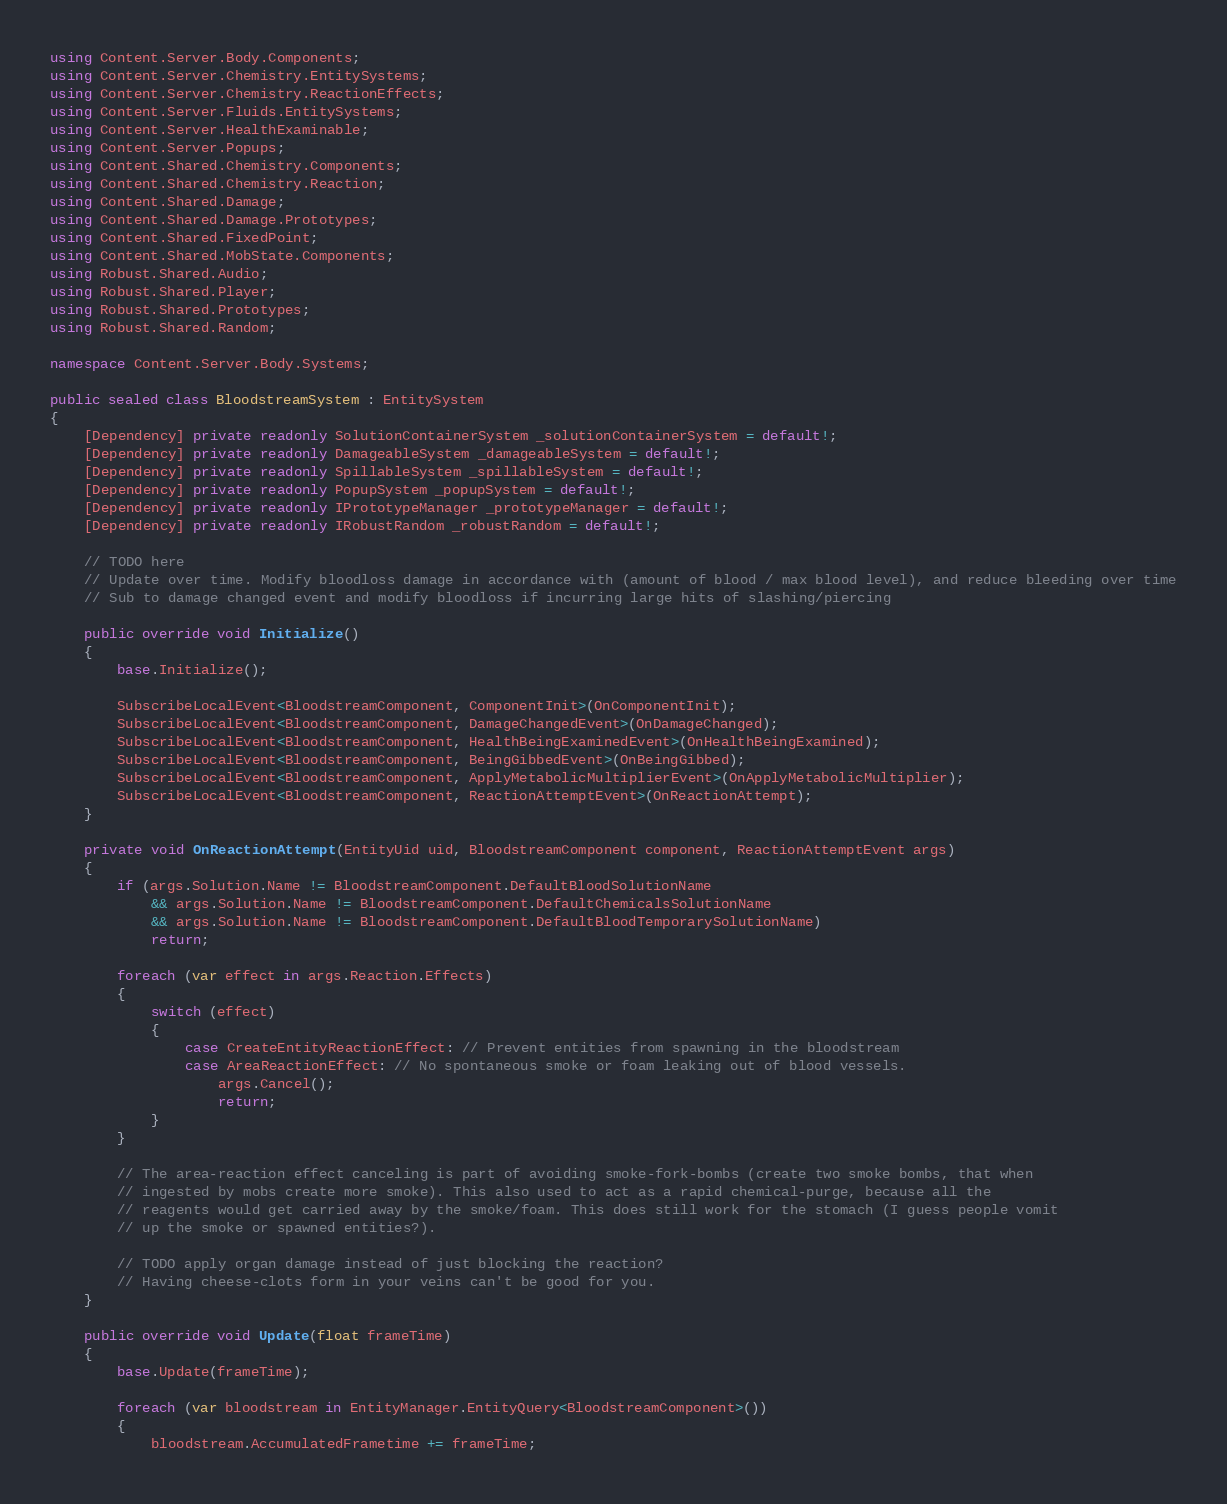Convert code to text. <code><loc_0><loc_0><loc_500><loc_500><_C#_>using Content.Server.Body.Components;
using Content.Server.Chemistry.EntitySystems;
using Content.Server.Chemistry.ReactionEffects;
using Content.Server.Fluids.EntitySystems;
using Content.Server.HealthExaminable;
using Content.Server.Popups;
using Content.Shared.Chemistry.Components;
using Content.Shared.Chemistry.Reaction;
using Content.Shared.Damage;
using Content.Shared.Damage.Prototypes;
using Content.Shared.FixedPoint;
using Content.Shared.MobState.Components;
using Robust.Shared.Audio;
using Robust.Shared.Player;
using Robust.Shared.Prototypes;
using Robust.Shared.Random;

namespace Content.Server.Body.Systems;

public sealed class BloodstreamSystem : EntitySystem
{
    [Dependency] private readonly SolutionContainerSystem _solutionContainerSystem = default!;
    [Dependency] private readonly DamageableSystem _damageableSystem = default!;
    [Dependency] private readonly SpillableSystem _spillableSystem = default!;
    [Dependency] private readonly PopupSystem _popupSystem = default!;
    [Dependency] private readonly IPrototypeManager _prototypeManager = default!;
    [Dependency] private readonly IRobustRandom _robustRandom = default!;

    // TODO here
    // Update over time. Modify bloodloss damage in accordance with (amount of blood / max blood level), and reduce bleeding over time
    // Sub to damage changed event and modify bloodloss if incurring large hits of slashing/piercing

    public override void Initialize()
    {
        base.Initialize();

        SubscribeLocalEvent<BloodstreamComponent, ComponentInit>(OnComponentInit);
        SubscribeLocalEvent<BloodstreamComponent, DamageChangedEvent>(OnDamageChanged);
        SubscribeLocalEvent<BloodstreamComponent, HealthBeingExaminedEvent>(OnHealthBeingExamined);
        SubscribeLocalEvent<BloodstreamComponent, BeingGibbedEvent>(OnBeingGibbed);
        SubscribeLocalEvent<BloodstreamComponent, ApplyMetabolicMultiplierEvent>(OnApplyMetabolicMultiplier);
        SubscribeLocalEvent<BloodstreamComponent, ReactionAttemptEvent>(OnReactionAttempt);
    }

    private void OnReactionAttempt(EntityUid uid, BloodstreamComponent component, ReactionAttemptEvent args)
    {
        if (args.Solution.Name != BloodstreamComponent.DefaultBloodSolutionName
            && args.Solution.Name != BloodstreamComponent.DefaultChemicalsSolutionName
            && args.Solution.Name != BloodstreamComponent.DefaultBloodTemporarySolutionName)
            return;

        foreach (var effect in args.Reaction.Effects)
        {
            switch (effect)
            {
                case CreateEntityReactionEffect: // Prevent entities from spawning in the bloodstream
                case AreaReactionEffect: // No spontaneous smoke or foam leaking out of blood vessels.
                    args.Cancel();
                    return;
            }
        }

        // The area-reaction effect canceling is part of avoiding smoke-fork-bombs (create two smoke bombs, that when
        // ingested by mobs create more smoke). This also used to act as a rapid chemical-purge, because all the
        // reagents would get carried away by the smoke/foam. This does still work for the stomach (I guess people vomit
        // up the smoke or spawned entities?).

        // TODO apply organ damage instead of just blocking the reaction?
        // Having cheese-clots form in your veins can't be good for you.
    }

    public override void Update(float frameTime)
    {
        base.Update(frameTime);

        foreach (var bloodstream in EntityManager.EntityQuery<BloodstreamComponent>())
        {
            bloodstream.AccumulatedFrametime += frameTime;
</code> 